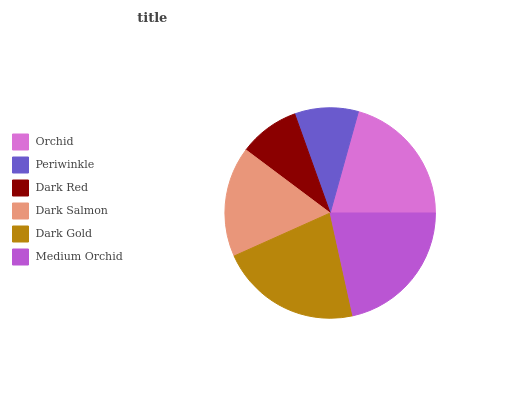Is Dark Red the minimum?
Answer yes or no. Yes. Is Dark Gold the maximum?
Answer yes or no. Yes. Is Periwinkle the minimum?
Answer yes or no. No. Is Periwinkle the maximum?
Answer yes or no. No. Is Orchid greater than Periwinkle?
Answer yes or no. Yes. Is Periwinkle less than Orchid?
Answer yes or no. Yes. Is Periwinkle greater than Orchid?
Answer yes or no. No. Is Orchid less than Periwinkle?
Answer yes or no. No. Is Orchid the high median?
Answer yes or no. Yes. Is Dark Salmon the low median?
Answer yes or no. Yes. Is Dark Gold the high median?
Answer yes or no. No. Is Dark Red the low median?
Answer yes or no. No. 